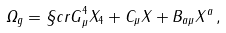Convert formula to latex. <formula><loc_0><loc_0><loc_500><loc_500>\varOmega _ { g } = { \S c r G } _ { \mu } ^ { 4 } X _ { 4 } + C _ { \mu } X + B _ { a \mu } X ^ { a } \, ,</formula> 